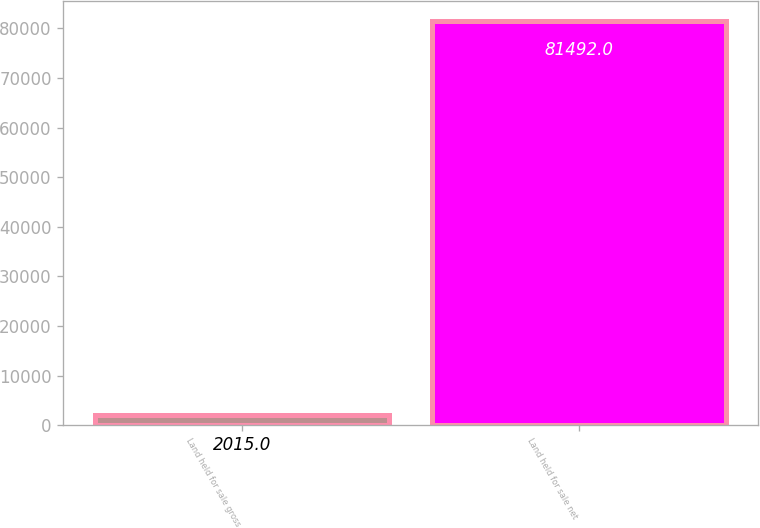Convert chart to OTSL. <chart><loc_0><loc_0><loc_500><loc_500><bar_chart><fcel>Land held for sale gross<fcel>Land held for sale net<nl><fcel>2015<fcel>81492<nl></chart> 